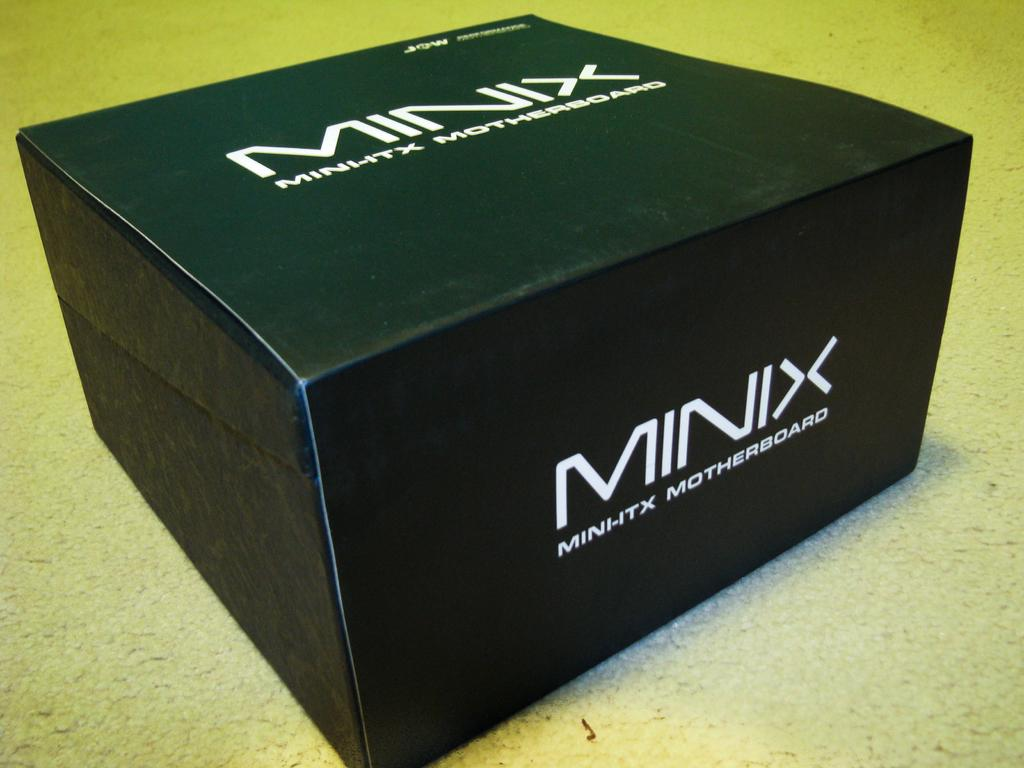<image>
Create a compact narrative representing the image presented. A black box that says Minix motherboard in white letters.. 